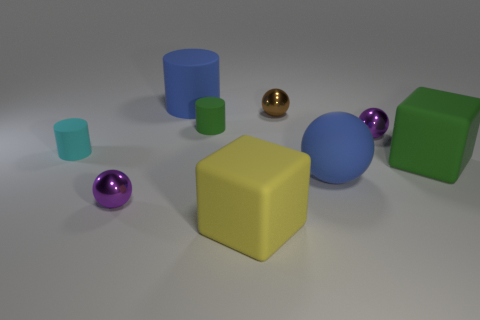Can you tell me the different colors of the objects present in the image? Certainly! In the image, there are objects in green, blue, yellow, and two shades of purple. Which object stands out the most to you in this collection? The yellow cube stands out due to its bold color and distinct shape amid spherical and cylindrical objects. 